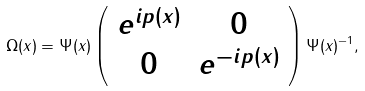Convert formula to latex. <formula><loc_0><loc_0><loc_500><loc_500>\Omega ( x ) = \Psi ( x ) \left ( \begin{array} { c c } e ^ { i p ( x ) } & 0 \\ 0 & e ^ { - i p ( x ) } \end{array} \right ) \Psi ( x ) ^ { - 1 } ,</formula> 